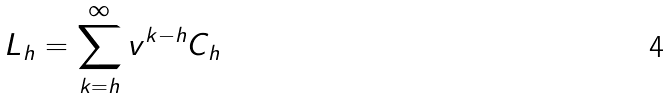Convert formula to latex. <formula><loc_0><loc_0><loc_500><loc_500>L _ { h } = \sum _ { k = h } ^ { \infty } v ^ { k - h } C _ { h }</formula> 